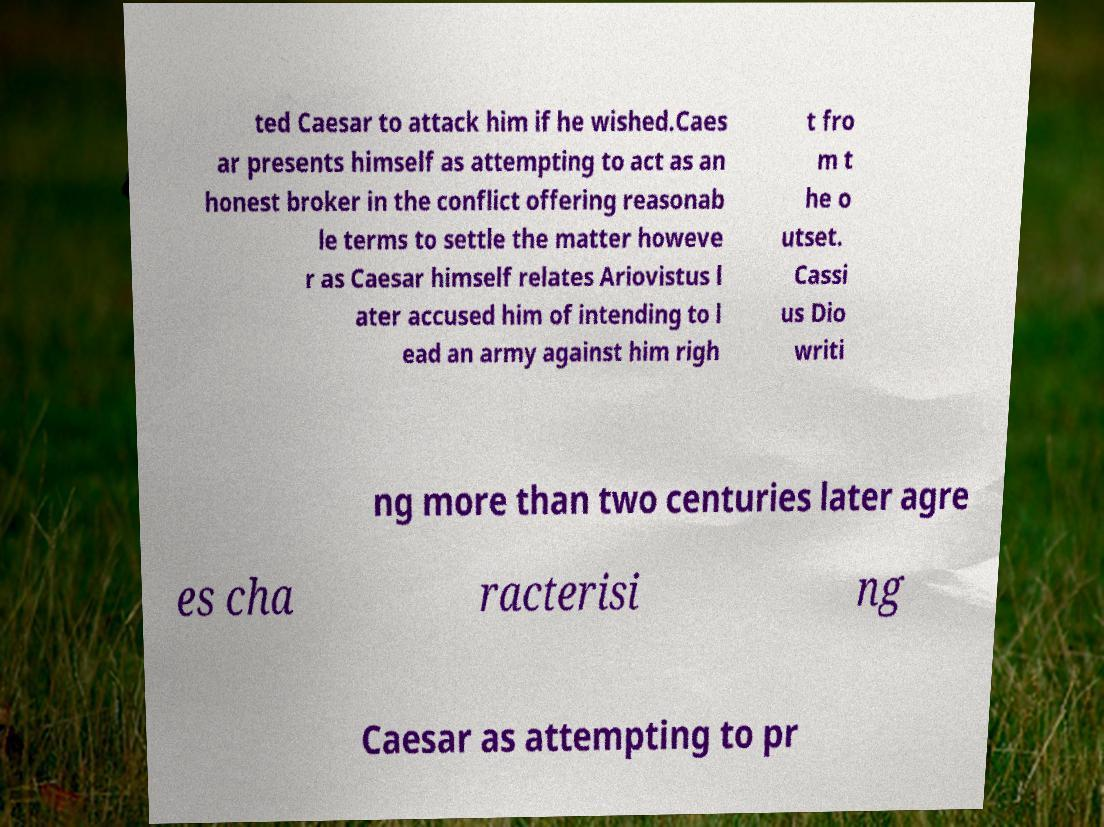Please read and relay the text visible in this image. What does it say? ted Caesar to attack him if he wished.Caes ar presents himself as attempting to act as an honest broker in the conflict offering reasonab le terms to settle the matter howeve r as Caesar himself relates Ariovistus l ater accused him of intending to l ead an army against him righ t fro m t he o utset. Cassi us Dio writi ng more than two centuries later agre es cha racterisi ng Caesar as attempting to pr 